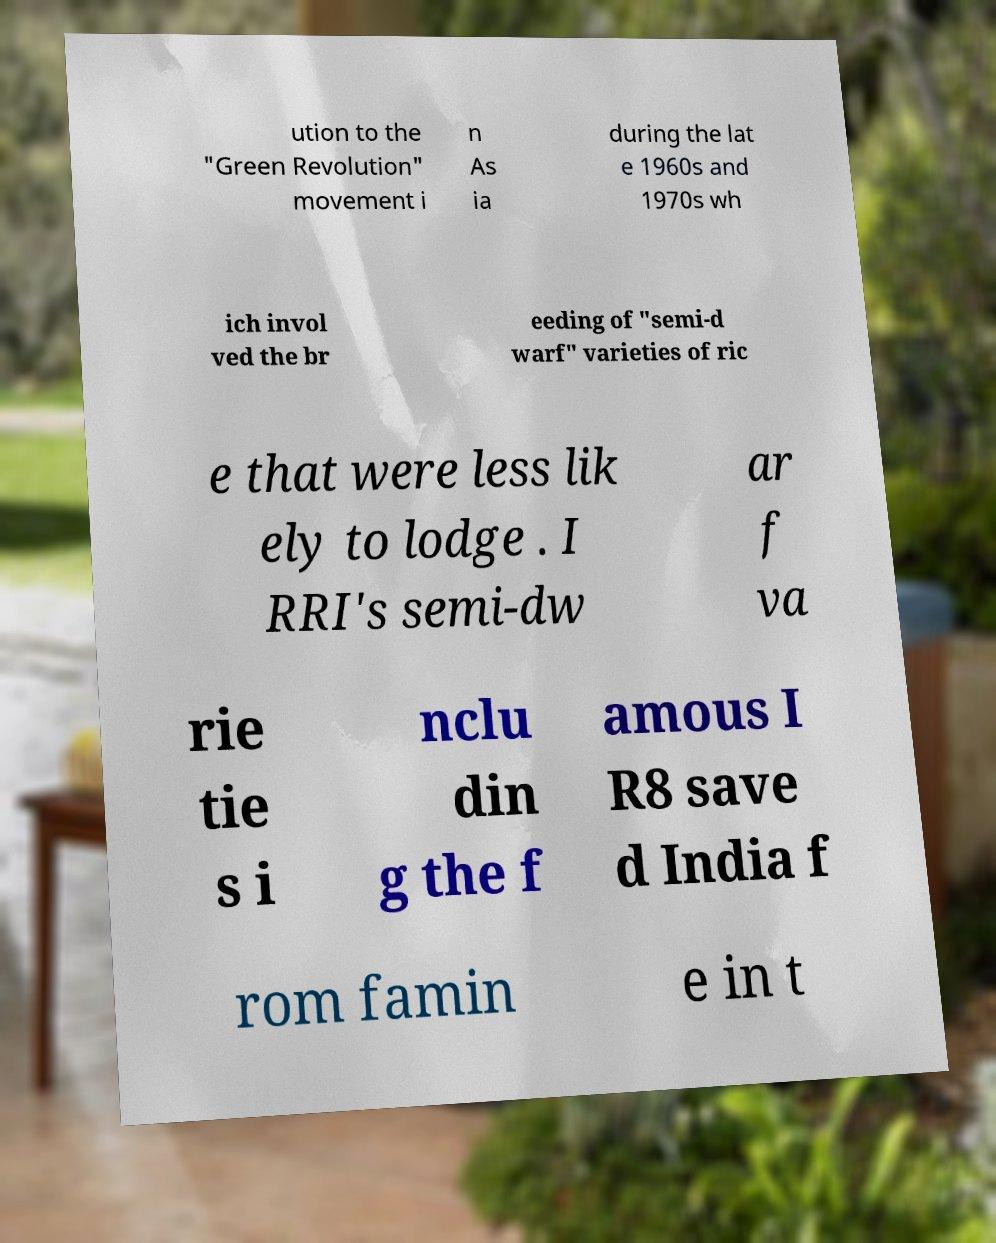There's text embedded in this image that I need extracted. Can you transcribe it verbatim? ution to the "Green Revolution" movement i n As ia during the lat e 1960s and 1970s wh ich invol ved the br eeding of "semi-d warf" varieties of ric e that were less lik ely to lodge . I RRI's semi-dw ar f va rie tie s i nclu din g the f amous I R8 save d India f rom famin e in t 